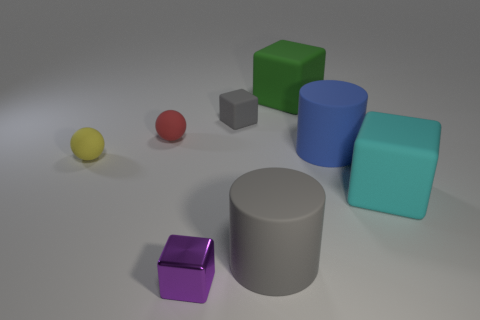Add 2 small cyan matte cylinders. How many objects exist? 10 Subtract all spheres. How many objects are left? 6 Add 3 small red matte balls. How many small red matte balls are left? 4 Add 4 big objects. How many big objects exist? 8 Subtract 1 gray blocks. How many objects are left? 7 Subtract all cyan rubber blocks. Subtract all small matte blocks. How many objects are left? 6 